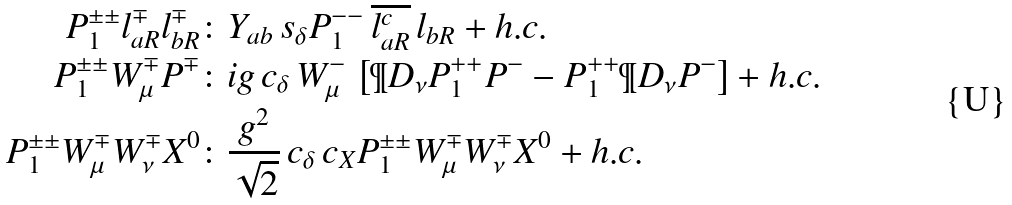Convert formula to latex. <formula><loc_0><loc_0><loc_500><loc_500>P _ { 1 } ^ { \pm \pm } l _ { a R } ^ { \mp } l _ { b R } ^ { \mp } & \colon Y _ { a b } \, s _ { \delta } P _ { 1 } ^ { - - } \, \overline { l _ { a R } ^ { c } } \, l _ { b R } + h . c . \\ P _ { 1 } ^ { \pm \pm } W _ { \mu } ^ { \mp } P ^ { \mp } & \colon i g \, c _ { \delta } \, W _ { \mu } ^ { - } \, \left [ \P D _ { \nu } P _ { 1 } ^ { + + } P ^ { - } - P _ { 1 } ^ { + + } \P D _ { \nu } P ^ { - } \right ] + h . c . \\ P _ { 1 } ^ { \pm \pm } W _ { \mu } ^ { \mp } W _ { \nu } ^ { \mp } X ^ { 0 } & \colon \frac { g ^ { 2 } } { \sqrt { 2 } } \, c _ { \delta } \, c _ { X } P _ { 1 } ^ { \pm \pm } W _ { \mu } ^ { \mp } W _ { \nu } ^ { \mp } X ^ { 0 } + h . c .</formula> 